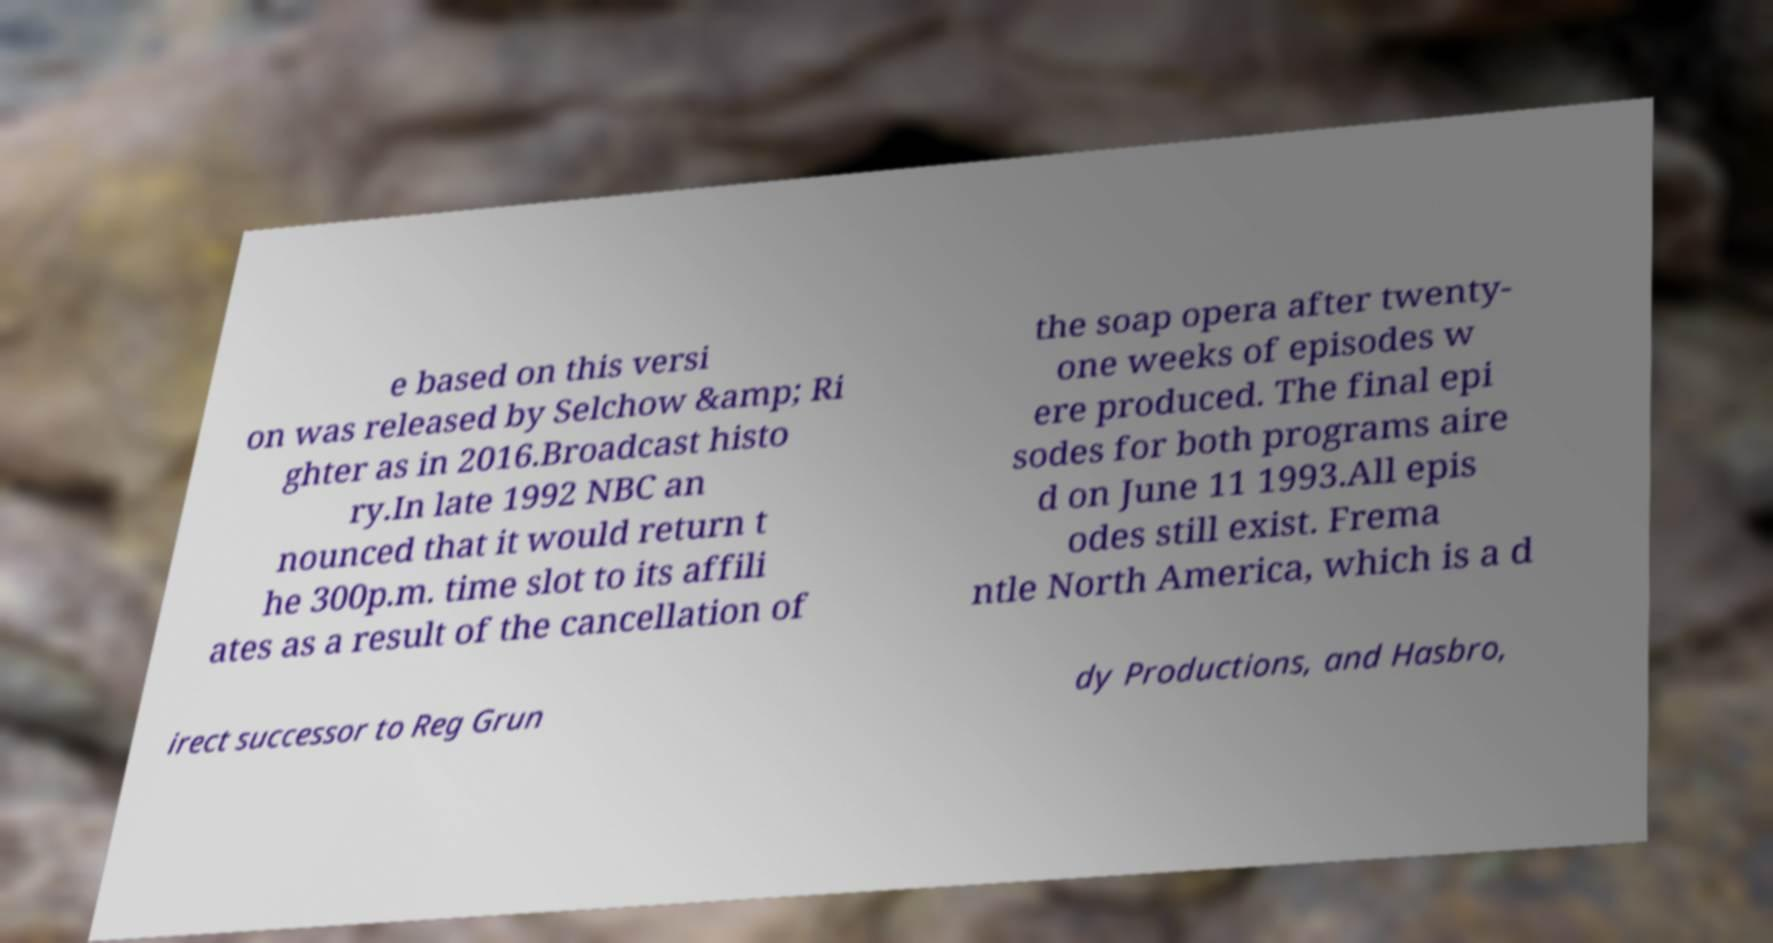Can you read and provide the text displayed in the image?This photo seems to have some interesting text. Can you extract and type it out for me? e based on this versi on was released by Selchow &amp; Ri ghter as in 2016.Broadcast histo ry.In late 1992 NBC an nounced that it would return t he 300p.m. time slot to its affili ates as a result of the cancellation of the soap opera after twenty- one weeks of episodes w ere produced. The final epi sodes for both programs aire d on June 11 1993.All epis odes still exist. Frema ntle North America, which is a d irect successor to Reg Grun dy Productions, and Hasbro, 